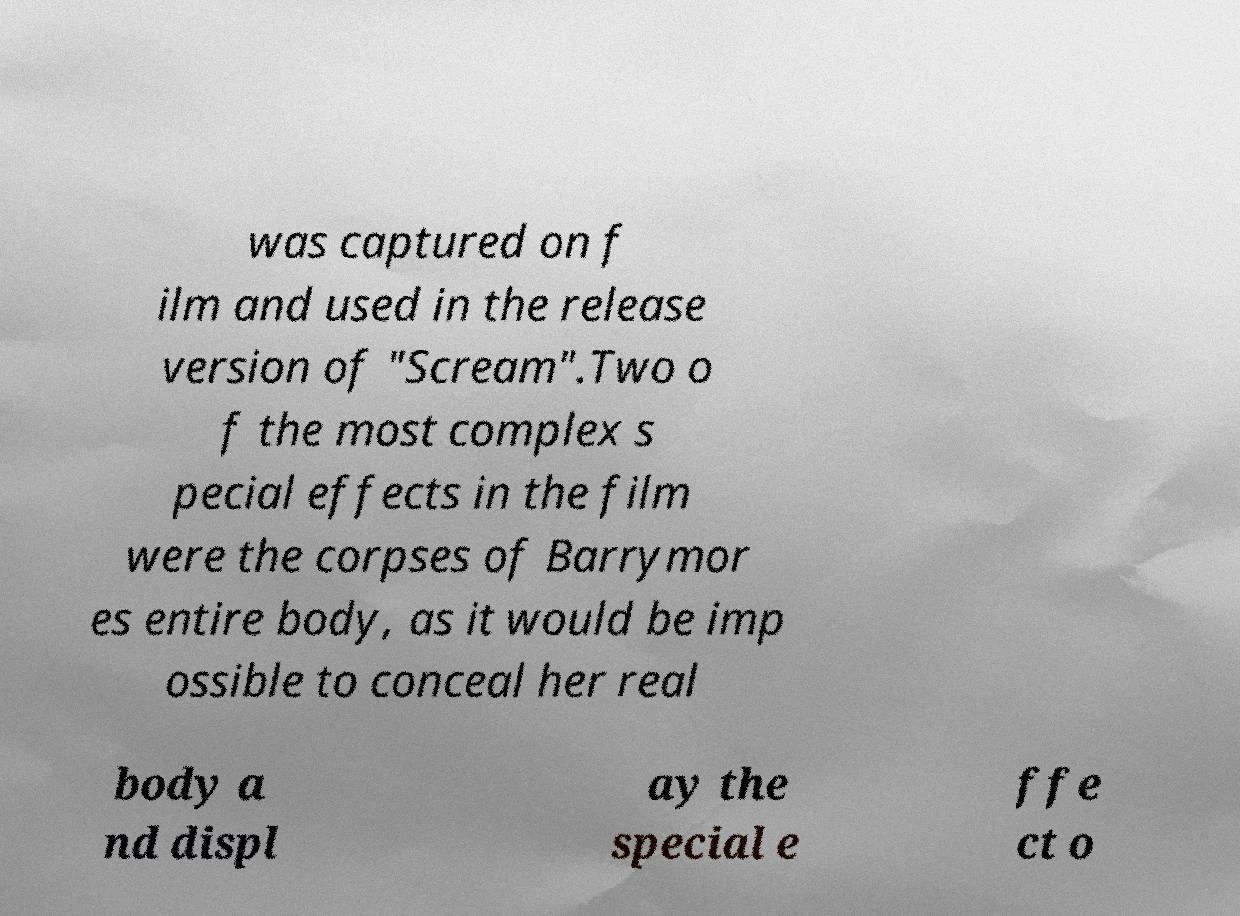Please identify and transcribe the text found in this image. was captured on f ilm and used in the release version of "Scream".Two o f the most complex s pecial effects in the film were the corpses of Barrymor es entire body, as it would be imp ossible to conceal her real body a nd displ ay the special e ffe ct o 